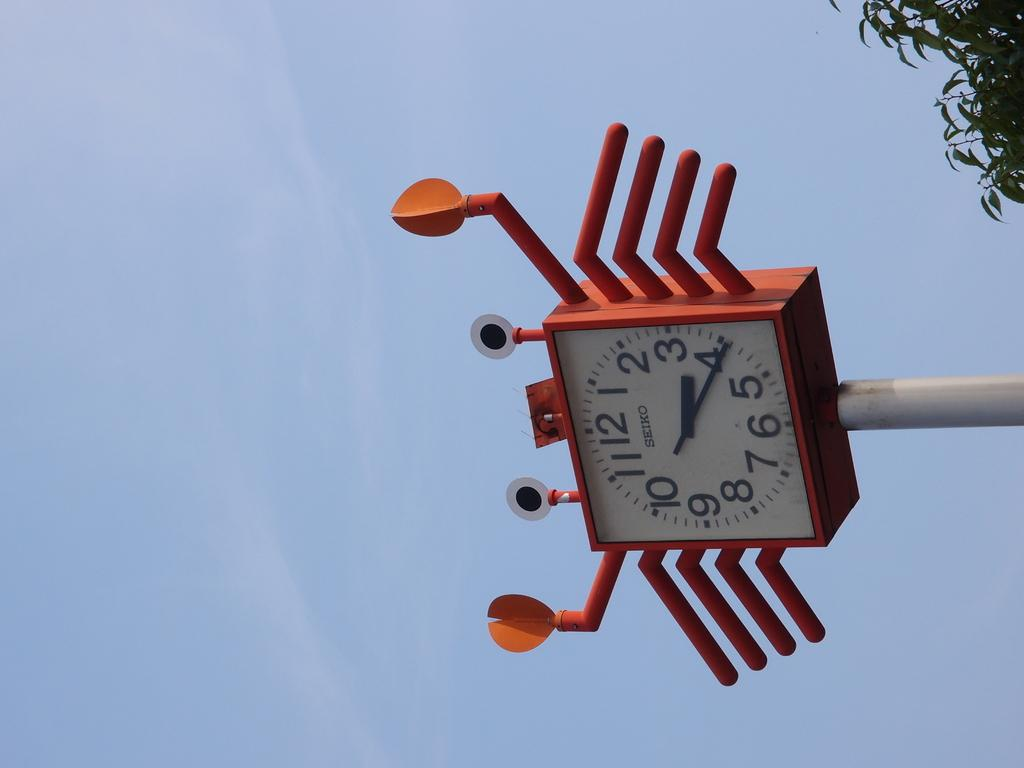What object is attached to the pole in the image? There is a clock attached to a pole in the image. What can be seen in the background of the image? There is a pool in the image. What is located near the pool in the image? There are leaves beside the pool in the image. What type of riddle is written on the leaves beside the pool in the image? There is no riddle written on the leaves beside the pool in the image. 